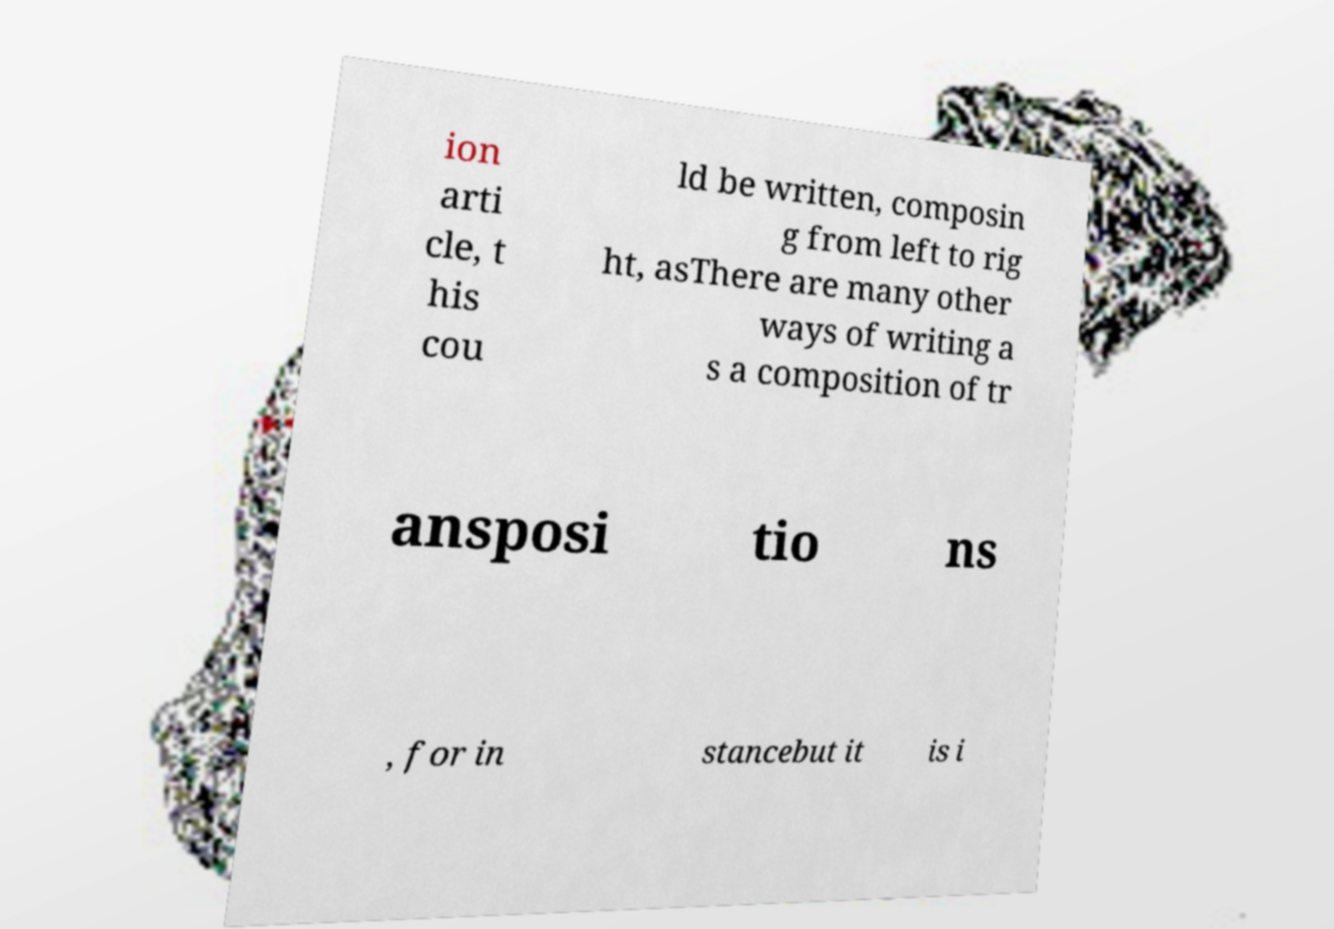What messages or text are displayed in this image? I need them in a readable, typed format. ion arti cle, t his cou ld be written, composin g from left to rig ht, asThere are many other ways of writing a s a composition of tr ansposi tio ns , for in stancebut it is i 